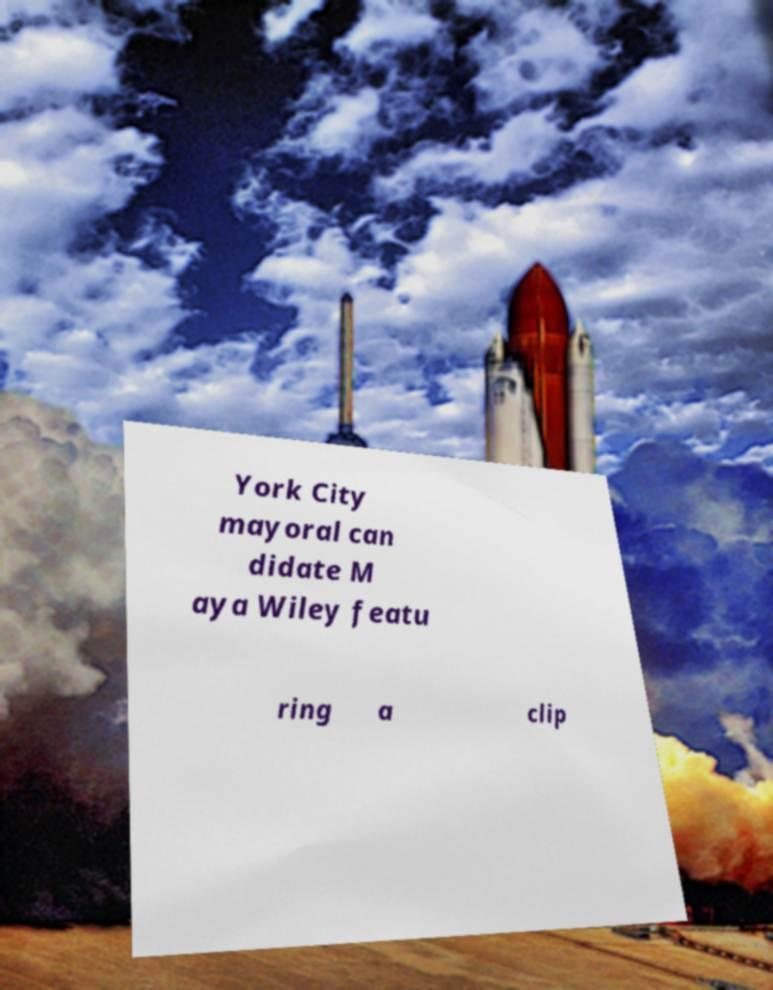I need the written content from this picture converted into text. Can you do that? York City mayoral can didate M aya Wiley featu ring a clip 